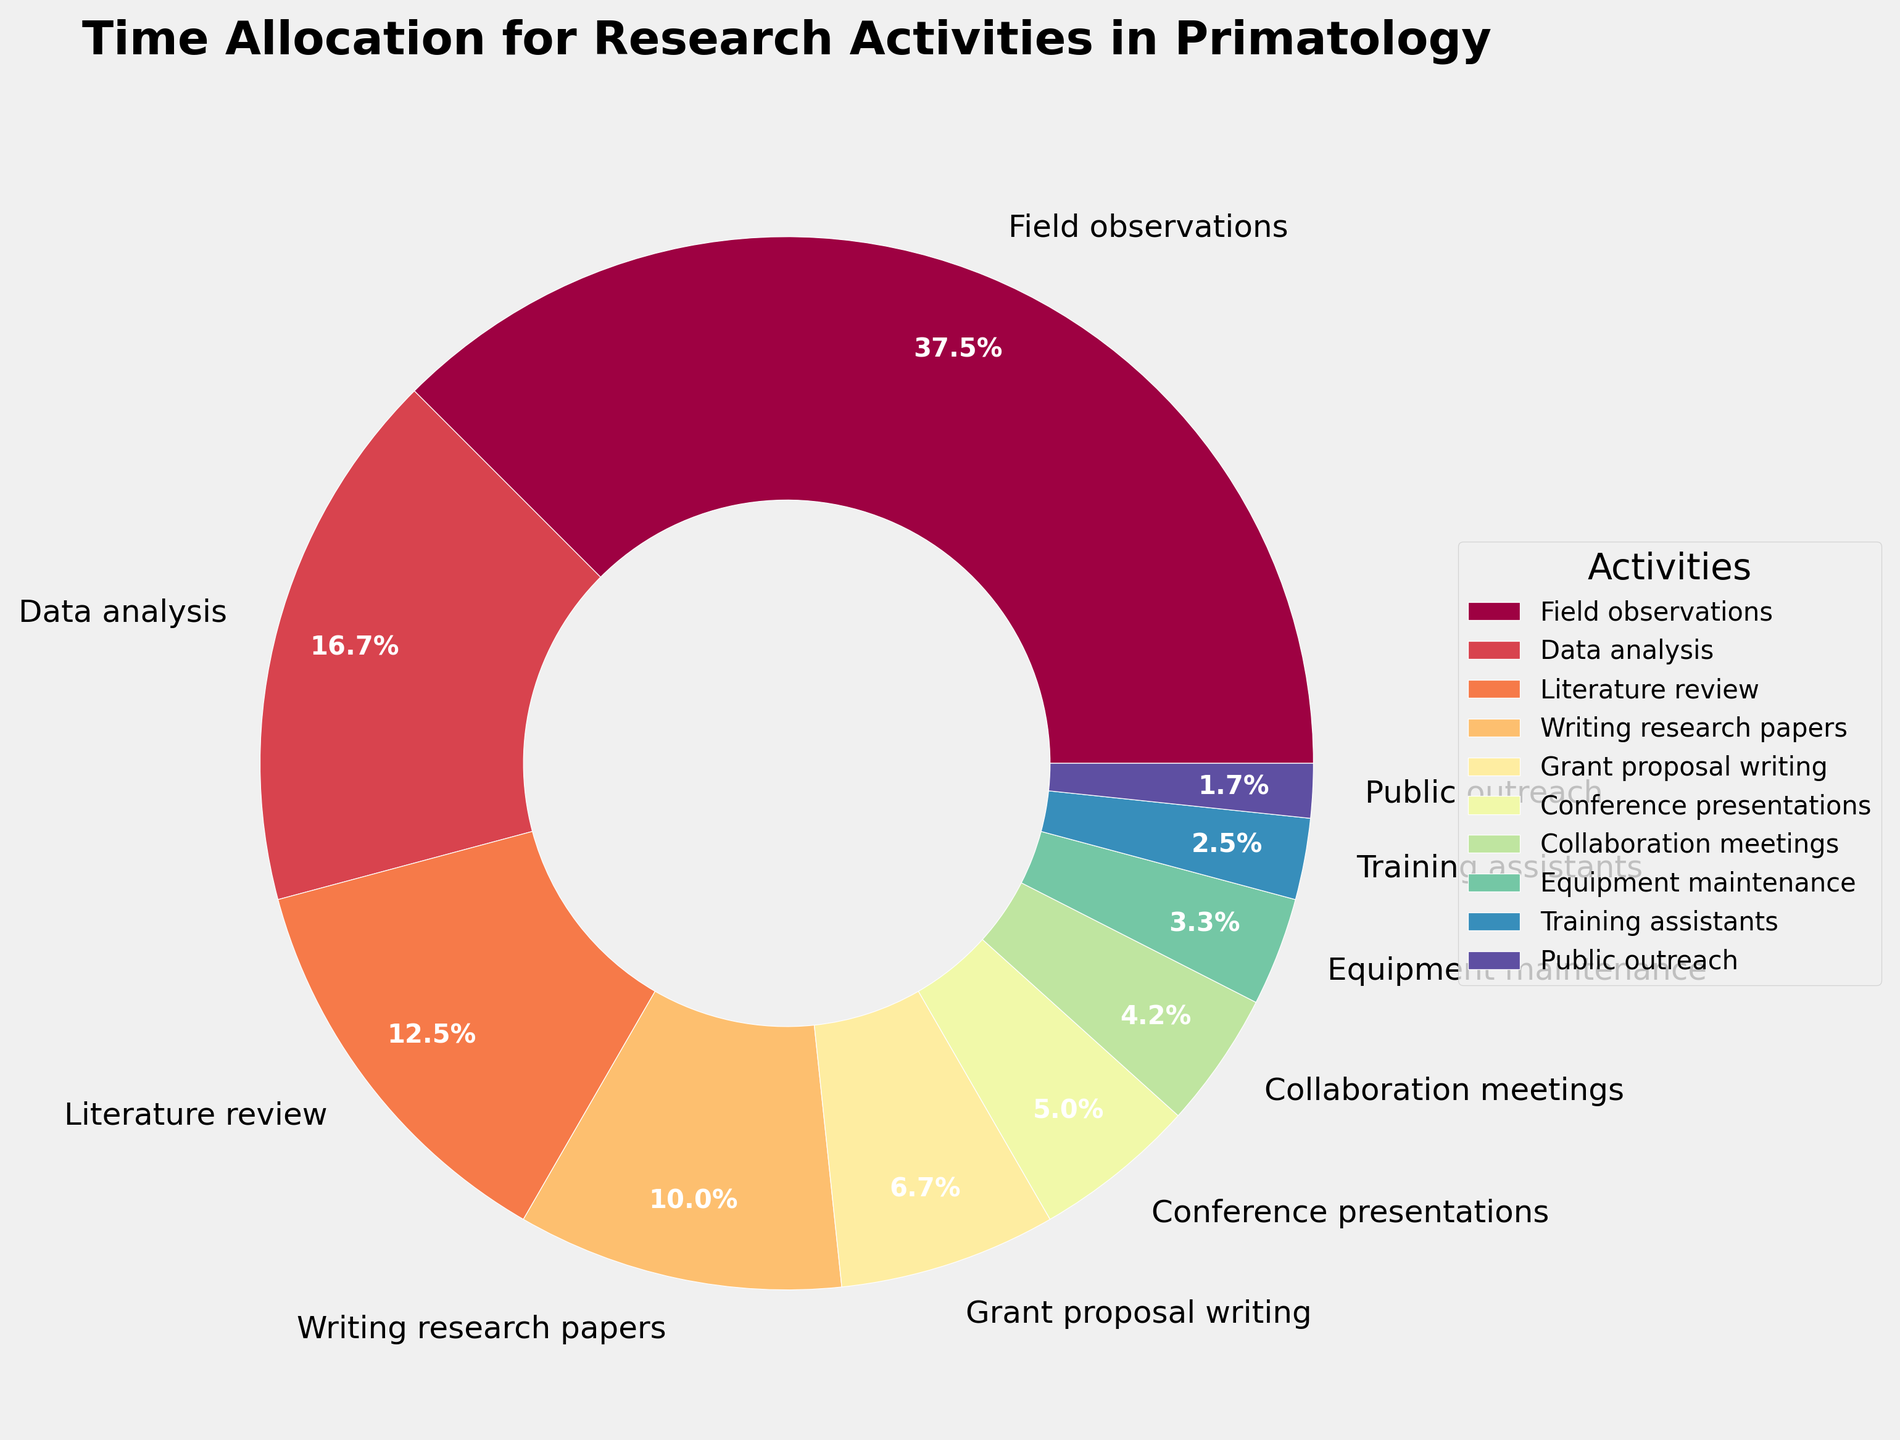Which activity takes up the highest percentage of time? The activity with the largest wedge in the pie chart is 'Field observations'. By looking at the size of the wedge, we can see it is the largest, and the label indicates it takes up 45 hours, which is more than any other activity.
Answer: Field observations Which two activities combined take up more than 'Data analysis'? The activities 'Writing research papers' (12 hours) and 'Grant proposal writing' (8 hours) combined equal 20 hours, the same as 'Data analysis'. We need to find another pair, 'Literature review' (15 hours) and 'Writing research papers' (12 hours) combined equal 27 hours, which is more than 'Data analysis'.
Answer: Literature review and Writing research papers How much more time is spent on 'Field observations' compared to 'Data analysis'? We check the hours for both activities: 'Field observations' is 45 hours and 'Data analysis' is 20 hours. The difference is 45 - 20 = 25 hours.
Answer: 25 hours Which activity uses the least amount of time? The smallest wedge on the pie chart represents 'Public outreach'. The label shows that it takes up 2 hours, which is fewer than any other activity.
Answer: Public outreach How many activities take up less than 10 hours each? To determine this, check the hours of each activity: 'Grant proposal writing', 'Conference presentations', 'Collaboration meetings', 'Equipment maintenance', 'Training assistants', and 'Public outreach' each take up fewer than 10 hours. Count these: there are 6 activities.
Answer: 6 activities What percentage of time is spent on 'Writing research papers'? The pie chart labels 'Writing research papers' as taking up 12 hours. The total hours for all activities are 120 hours. Calculate the percentage: (12 / 120) * 100 = 10%.
Answer: 10% Which activity uses more hours: 'Grant proposal writing' or 'Conference presentations'? By looking at the pie chart, 'Grant proposal writing' is labeled with 8 hours, and 'Conference presentations' is labeled with 6 hours. Comparing these, 'Grant proposal writing' uses more hours.
Answer: Grant proposal writing How do the hours spent on 'Training assistants' compare to the hours spent on 'Equipment maintenance'? 'Training assistants' is marked with 3 hours, while 'Equipment maintenance' is marked with 4 hours. 'Equipment maintenance' has 1 more hour than 'Training assistants'.
Answer: Equipment maintenance has 1 more hour What is the total number of hours spent on 'Collaboration meetings' and 'Equipment maintenance' together? 'Collaboration meetings' take 5 hours and 'Equipment maintenance' takes 4 hours. Summing these gives 5 + 4 = 9 hours.
Answer: 9 hours What is the average time spent on 'Data analysis', 'Literature review', and 'Writing research papers'? Check the hours for each: 'Data analysis' (20 hours), 'Literature review' (15 hours), and 'Writing research papers' (12 hours). Sum these: 20 + 15 + 12 = 47 hours, and calculate the average: 47 / 3 ≈ 15.67 hours.
Answer: 15.67 hours 